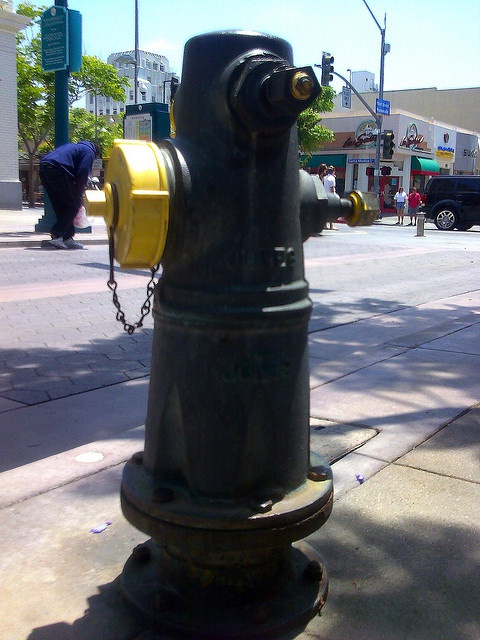Describe the objects in this image and their specific colors. I can see fire hydrant in darkgray, black, olive, and gray tones, people in darkgray, black, navy, and blue tones, truck in darkgray, black, navy, and gray tones, traffic light in darkgray, navy, blue, gray, and white tones, and people in darkgray, gray, lightblue, lavender, and black tones in this image. 